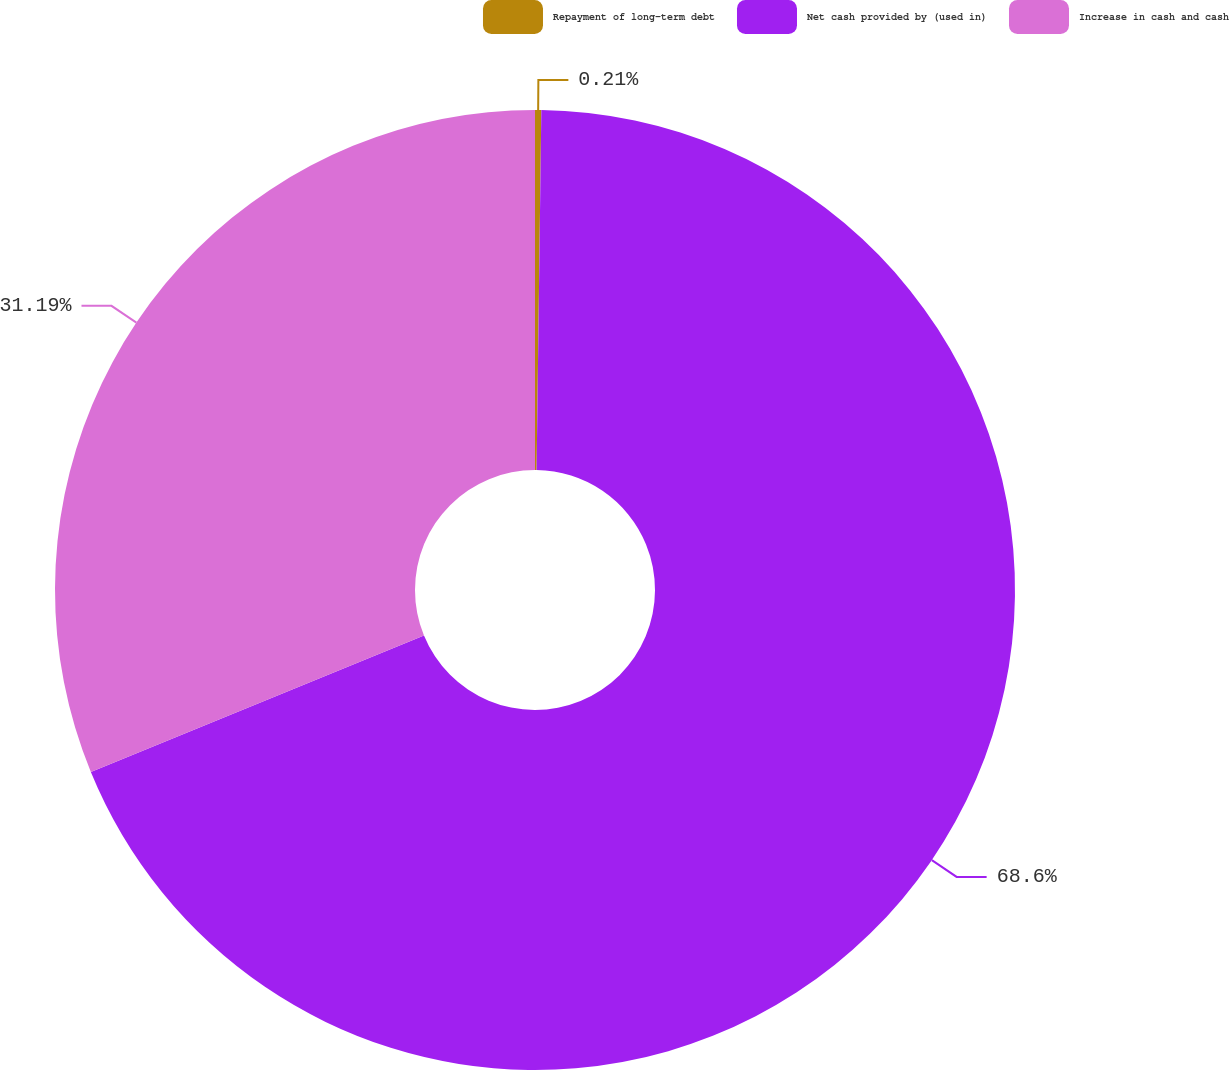<chart> <loc_0><loc_0><loc_500><loc_500><pie_chart><fcel>Repayment of long-term debt<fcel>Net cash provided by (used in)<fcel>Increase in cash and cash<nl><fcel>0.21%<fcel>68.6%<fcel>31.19%<nl></chart> 